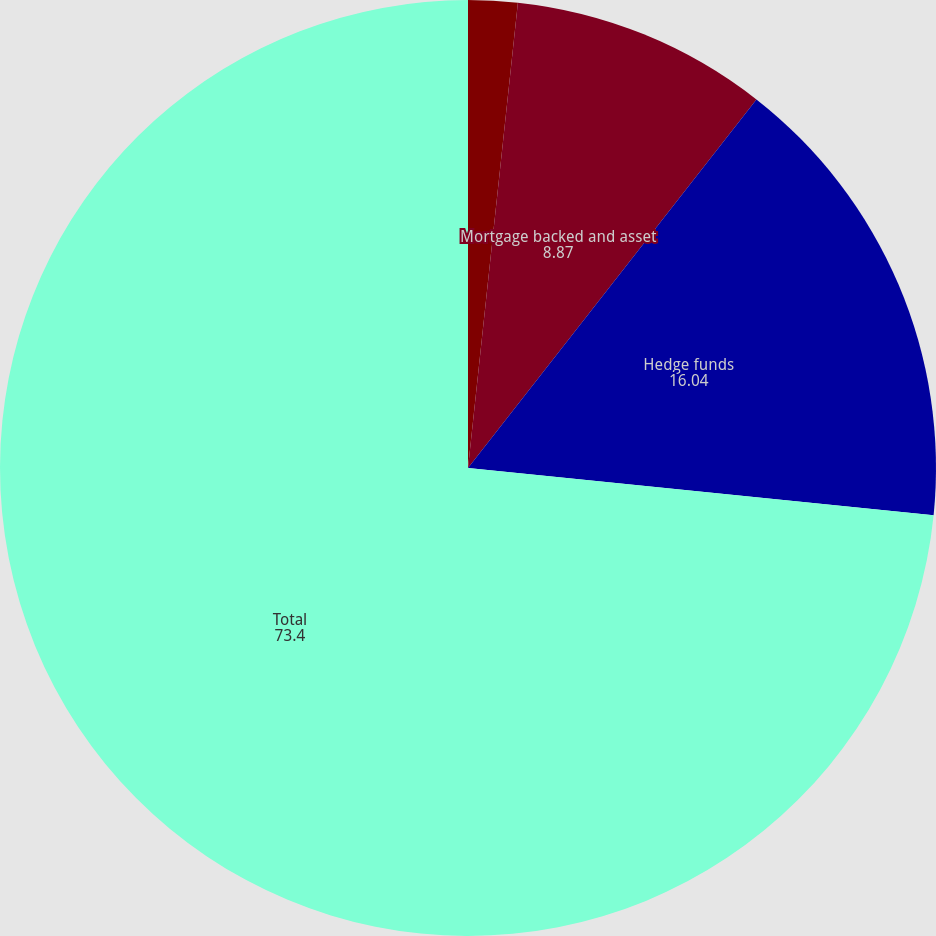Convert chart. <chart><loc_0><loc_0><loc_500><loc_500><pie_chart><fcel>Corporate<fcel>Mortgage backed and asset<fcel>Hedge funds<fcel>Total<nl><fcel>1.7%<fcel>8.87%<fcel>16.04%<fcel>73.4%<nl></chart> 